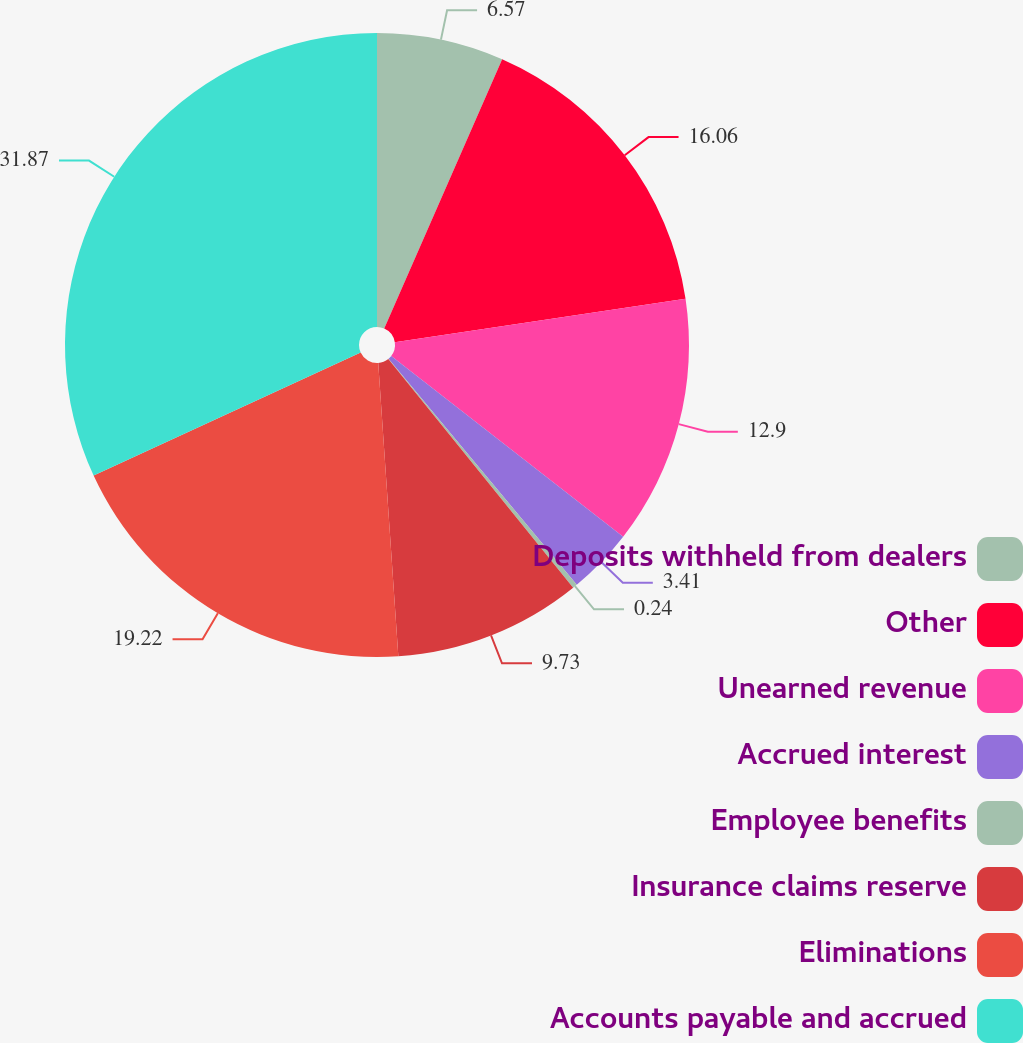<chart> <loc_0><loc_0><loc_500><loc_500><pie_chart><fcel>Deposits withheld from dealers<fcel>Other<fcel>Unearned revenue<fcel>Accrued interest<fcel>Employee benefits<fcel>Insurance claims reserve<fcel>Eliminations<fcel>Accounts payable and accrued<nl><fcel>6.57%<fcel>16.06%<fcel>12.9%<fcel>3.41%<fcel>0.24%<fcel>9.73%<fcel>19.22%<fcel>31.87%<nl></chart> 